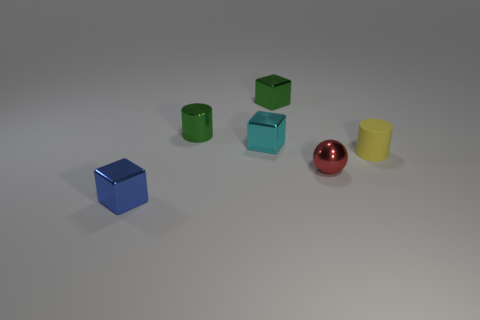Are there any other things that are the same shape as the tiny red shiny object?
Make the answer very short. No. There is a small rubber cylinder; is its color the same as the small metal cube that is in front of the small yellow cylinder?
Your answer should be compact. No. There is a cylinder that is on the left side of the rubber cylinder; what material is it?
Your answer should be very brief. Metal. Are there any other small objects that have the same color as the matte thing?
Offer a very short reply. No. What is the color of the other cylinder that is the same size as the shiny cylinder?
Offer a very short reply. Yellow. How many tiny things are either yellow cylinders or things?
Offer a very short reply. 6. Is the number of tiny metallic cylinders behind the small blue object the same as the number of spheres in front of the small red object?
Your answer should be compact. No. How many cylinders have the same size as the yellow thing?
Offer a very short reply. 1. What number of yellow things are large objects or matte objects?
Offer a terse response. 1. Are there an equal number of green blocks that are in front of the small green metal cube and small blue matte spheres?
Make the answer very short. Yes. 